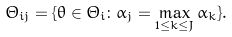<formula> <loc_0><loc_0><loc_500><loc_500>\Theta _ { i j } = \{ \theta \in \Theta _ { i } \colon \alpha _ { j } = \max _ { 1 \leq k \leq J } \alpha _ { k } \} .</formula> 